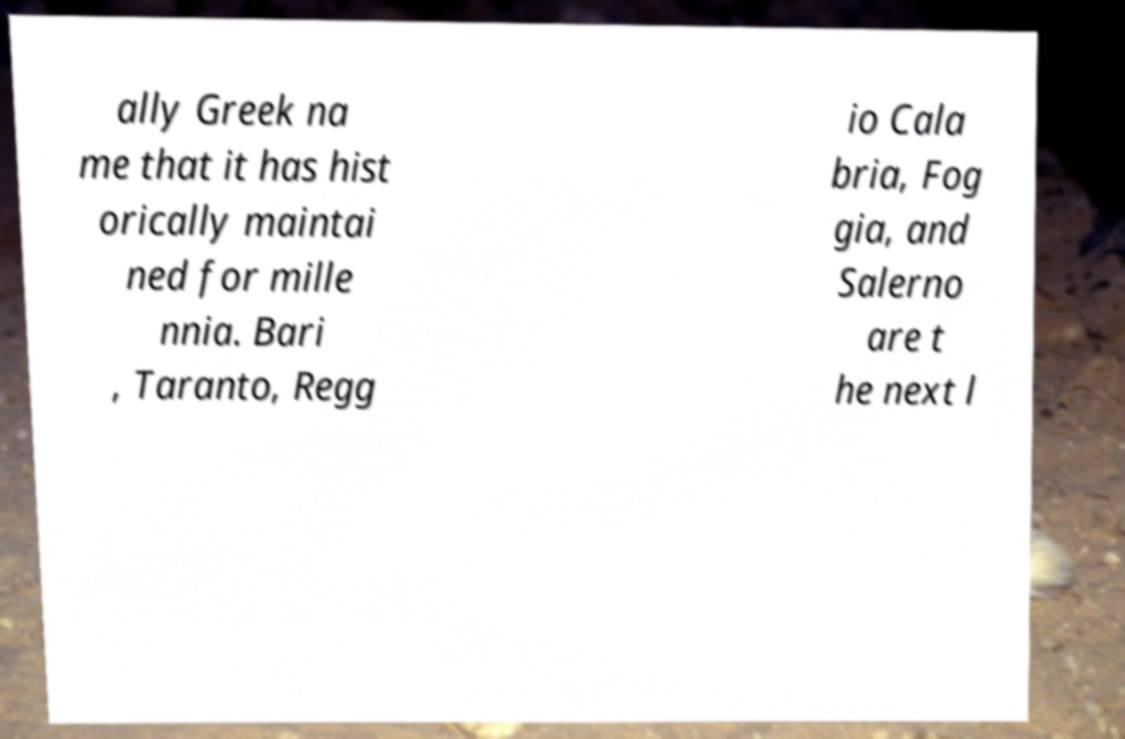Could you assist in decoding the text presented in this image and type it out clearly? ally Greek na me that it has hist orically maintai ned for mille nnia. Bari , Taranto, Regg io Cala bria, Fog gia, and Salerno are t he next l 